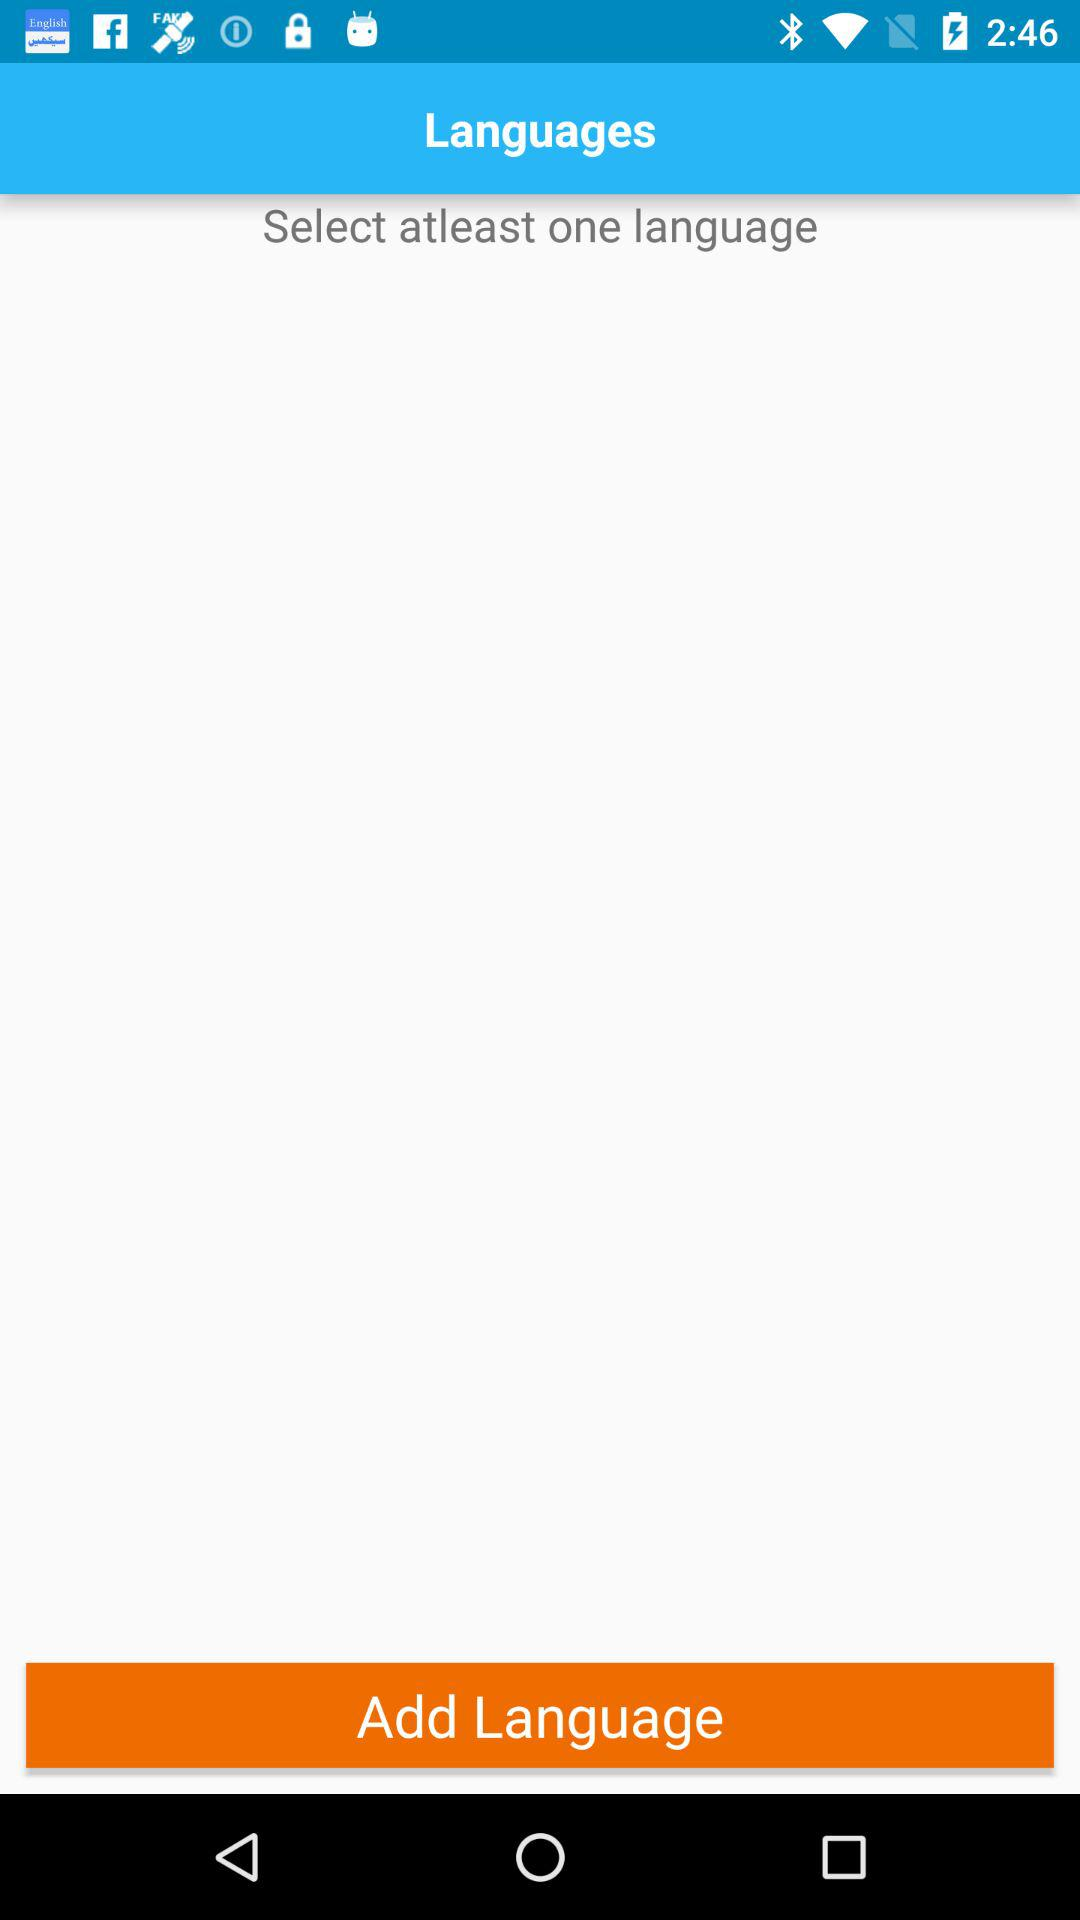How many languages are currently selected?
Answer the question using a single word or phrase. 0 